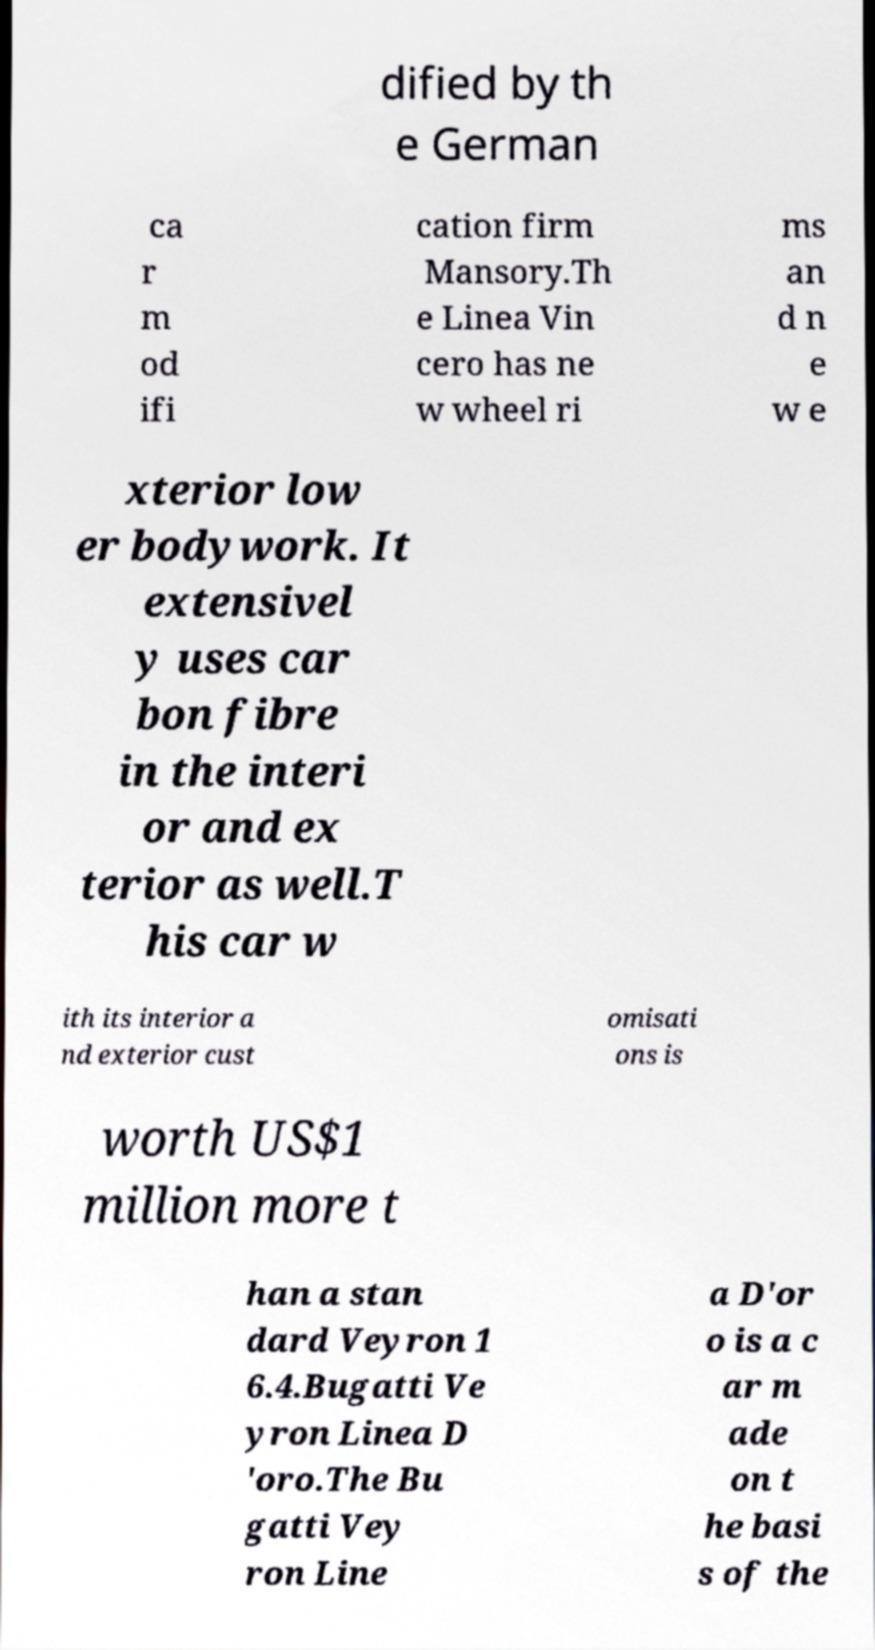What messages or text are displayed in this image? I need them in a readable, typed format. dified by th e German ca r m od ifi cation firm Mansory.Th e Linea Vin cero has ne w wheel ri ms an d n e w e xterior low er bodywork. It extensivel y uses car bon fibre in the interi or and ex terior as well.T his car w ith its interior a nd exterior cust omisati ons is worth US$1 million more t han a stan dard Veyron 1 6.4.Bugatti Ve yron Linea D 'oro.The Bu gatti Vey ron Line a D'or o is a c ar m ade on t he basi s of the 